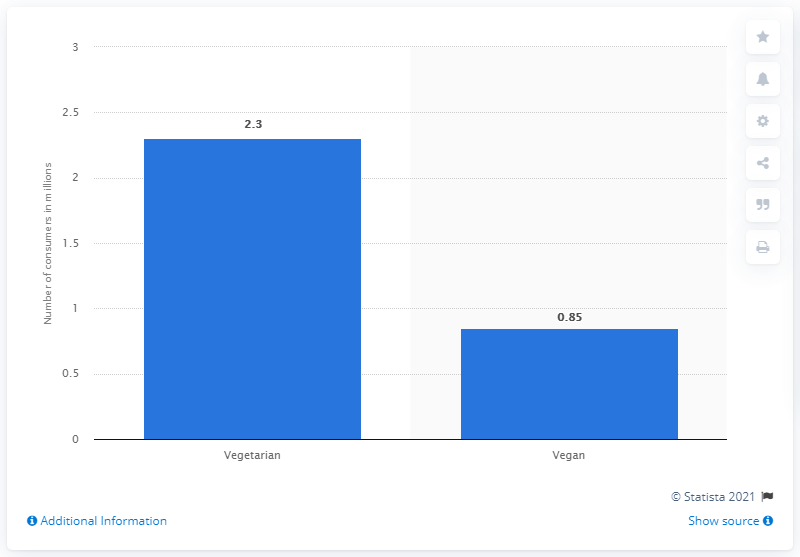Highlight a few significant elements in this photo. In 2018, only 0.85% of Canadians identified as vegan. In 2018, it is estimated that approximately 2.3 million Canadians followed a vegetarian diet. 